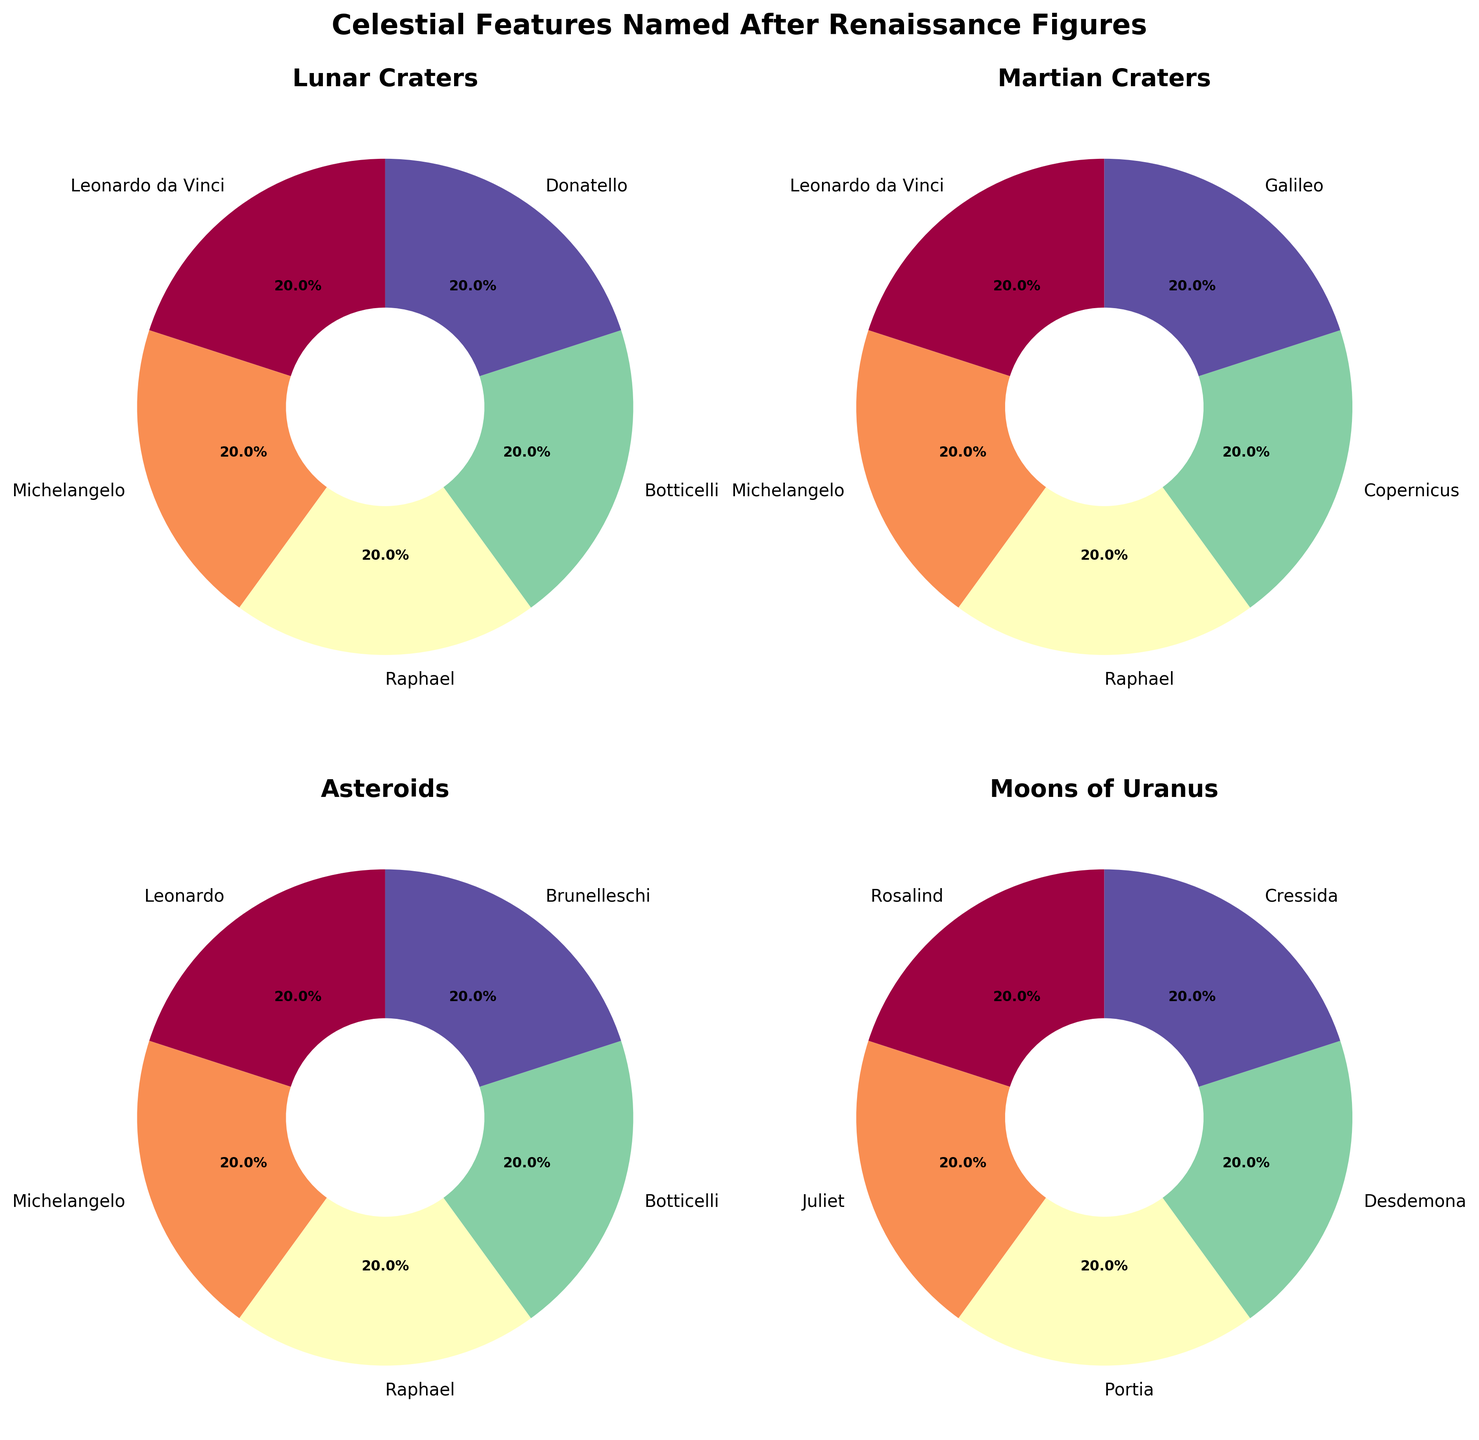Which category has the highest number of features named after Renaissance figures? From the pie charts, each feature contributes equally to its respective category. The 'Moons of Uranus' category has 5 features, more than any other category.
Answer: Moons of Uranus How many celestial features are named after Leonardo da Vinci and Leonardo combined? The 'Leonardo da Vinci' (Lunar Craters and Martian Craters) and 'Leonardo' (Asteroids) add up to 3 features based on the pie charts.
Answer: 3 Which categories have features named after Michelangelo? The pie charts for 'Lunar Craters', 'Martian Craters', and 'Asteroids' all show a section for Michelangelo.
Answer: Lunar Craters, Martian Craters, Asteroids Is there a category with more than one feature named after Raphael? By examining the pie charts, 'Lunar Craters', 'Martian Craters', and 'Asteroids' each contain one feature named after Raphael. No category has more than one.
Answer: No What is the ratio of Lunar Craters to Martian Craters named after Renaissance figures? Each has 5 features as seen on their respective pie charts. Thus, the ratio is 5:5 or 1:1 after simplification.
Answer: 1:1 Which category includes features named after Copernicus and Galileo? The pie chart for 'Martian Craters' includes sections for both Copernicus and Galileo.
Answer: Martian Craters What percentage of the total features named after Renaissance figures are Moons of Uranus? There are 5 features in 'Moons of Uranus' out of a total of 20 across all categories. This is (5/20) * 100% = 25%.
Answer: 25% How many categories feature Donatello? The Donatello feature appears only in the 'Lunar Craters' pie chart. So, there is only one category.
Answer: 1 Compare the number of features named after artists versus scientists. Artists (Leonardo da Vinci, Michelangelo, Raphael, Botticelli, Donatello, Brunelleschi) appear 13 times across all categories, while scientists (Copernicus, Galileo) appear twice.
Answer: More artists than scientists If you were to combine the Lunar and Martian Craters, what would the new total count be? Lunar Craters have 5 and Martian Craters have 5, combining them results in 5 + 5 = 10.
Answer: 10 